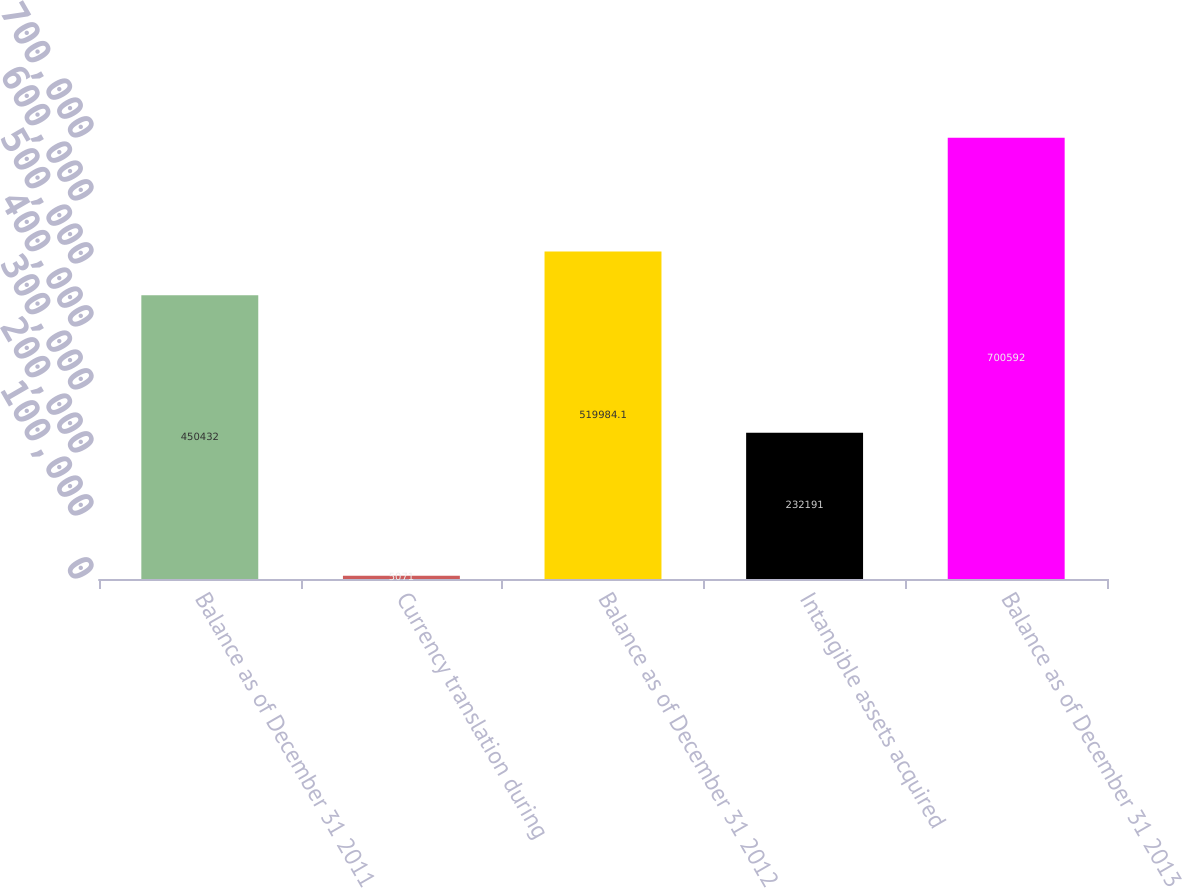Convert chart to OTSL. <chart><loc_0><loc_0><loc_500><loc_500><bar_chart><fcel>Balance as of December 31 2011<fcel>Currency translation during<fcel>Balance as of December 31 2012<fcel>Intangible assets acquired<fcel>Balance as of December 31 2013<nl><fcel>450432<fcel>5071<fcel>519984<fcel>232191<fcel>700592<nl></chart> 